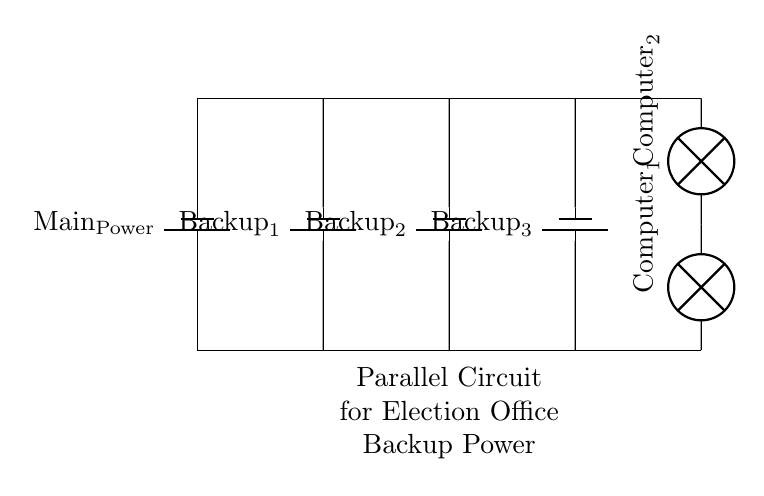What type of circuit is this? This circuit is a parallel circuit, as indicated by the multiple paths connecting the backup power supplies to the computers. In a parallel circuit, each component is connected directly across the same two points, allowing for independent operation.
Answer: Parallel How many backup power supplies are connected? There are three backup power supplies shown in the circuit, which can be counted as there are three batteries labeled Backup 1, Backup 2, and Backup 3 connected in parallel.
Answer: Three What do the lamps represent in this circuit? The lamps symbolize the election office computers, with each lamp representing one computer connected to the parallel circuit. The labels indicate their function in the system.
Answer: Computers What happens if one backup power supply fails? If one backup power supply fails, the other two will still provide power to the computers because they are connected in parallel. This ensures that the failure of one does not affect the overall functionality of the circuit.
Answer: No impact What is in the circuit's main power supply? The main power supply is indicated by the component labeled Main Power, which serves as the primary source of electricity for the circuit and is connected to the backup supplies.
Answer: Main Power What is the purpose of a parallel circuit in this scenario? The purpose of using a parallel circuit is to ensure redundancy and reliability for powering the election office computers. This configuration allows multiple backup supplies to work simultaneously and independently to maintain power if one source fails.
Answer: Redundancy Which component type is used for the backup power supplies? The backup power supplies are represented by batteries, specifically two different types of batteries, indicating that they provide DC voltage to the circuit while being connected in parallel.
Answer: Batteries 